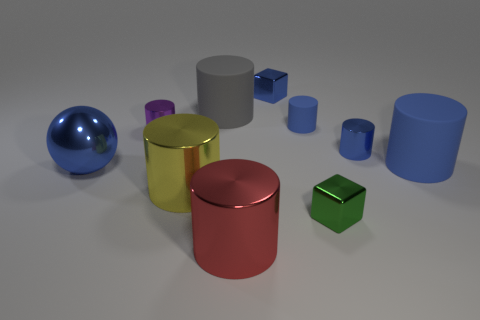How many things are small blue metallic cubes or cylinders?
Ensure brevity in your answer.  8. Is the large blue thing on the left side of the small rubber object made of the same material as the tiny thing that is left of the big red metal object?
Provide a short and direct response. Yes. There is a ball that is the same material as the red cylinder; what is its color?
Provide a succinct answer. Blue. What number of red metal things are the same size as the blue metal cube?
Your response must be concise. 0. How many other objects are there of the same color as the metal sphere?
Offer a very short reply. 4. Is there anything else that is the same size as the red cylinder?
Provide a succinct answer. Yes. Does the big metal thing that is to the left of the yellow metal object have the same shape as the matte thing in front of the tiny blue metal cylinder?
Offer a very short reply. No. What is the shape of the rubber object that is the same size as the purple cylinder?
Offer a terse response. Cylinder. Are there an equal number of red cylinders behind the tiny blue metal cube and tiny purple cylinders to the right of the large blue cylinder?
Offer a very short reply. Yes. Are there any other things that are the same shape as the large blue shiny thing?
Keep it short and to the point. No. 